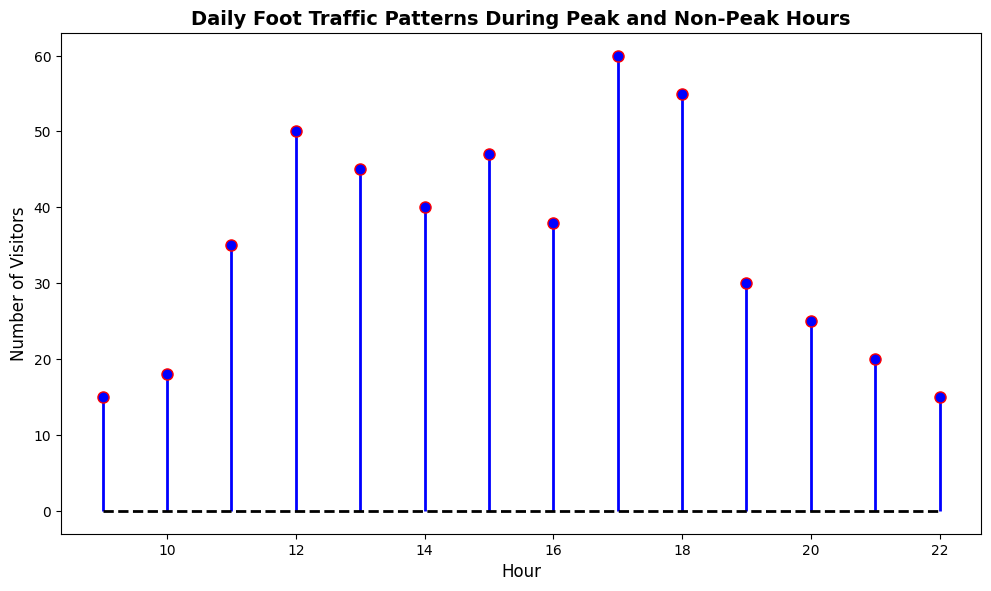Which hour had the highest number of visitors? Look at the stem plot and identify the hour at which the highest point occurs. This point, with a height representative of 60 visitors, is at hour 17.
Answer: 17 Which hour had the fewest visitors, and how many were there? Find the point with the lowest height on the stem plot. This point appears at hour 09 and hour 22, both with 15 visitors.
Answer: 09 and 22, 15 During which hours do visitors exceed 50? Identify the points that are higher than 50 on the stem plot. These points are at hour 12 (50), hour 17 (60), and hour 18 (55).
Answer: 17, 18 What is the total number of visitors from 12 PM to 3 PM (inclusive)? Sum the number of visitors from hours 12 to 15 on the stem plot: 50 (12 PM) + 45 (1 PM) + 40 (2 PM) + 47 (3 PM) = 182.
Answer: 182 What is the difference in the number of visitors between 10 AM and 12 PM? Subtract the number of visitors at 10 AM (18) from the number at 12 PM (50). 50 - 18 = 32.
Answer: 32 How many visitors are there on average between 5 PM and 8 PM (inclusive)? Sum the number of visitors between 5 PM and 8 PM, then divide by the count of hours: (60 + 55 + 30 + 25) / 4 = 170 / 4 = 42.5.
Answer: 42.5 What is the trend in visitor numbers from 11 AM to 1 PM? Looking at the stem plot, we can see the number of visitors increases from 35 at 11 AM to 50 at 12 PM and then slightly decreases to 45 at 1 PM.
Answer: Increasing and then decreasing Which hour marks the beginning of the peak foot traffic period (more than 40 visitors)? Locate the first hour when the number of visitors exceeds 40. On the stem plot, this is at 12 PM with 50 visitors.
Answer: 12 PM How does the baseline of the plot appear visually? The baseline on the stem plot is shown as a red dashed line. This is consistent across the entire plot.
Answer: Red dashed line Compare the number of visitors at 3 PM and 7 PM. Which hour has more visitors and by how much? Compare the heights of the points at 3 PM (47 visitors) and 7 PM (30 visitors). Subtract 30 from 47: 47 - 30 = 17. Therefore, 3 PM has 17 more visitors than 7 PM.
Answer: 3 PM, 17 